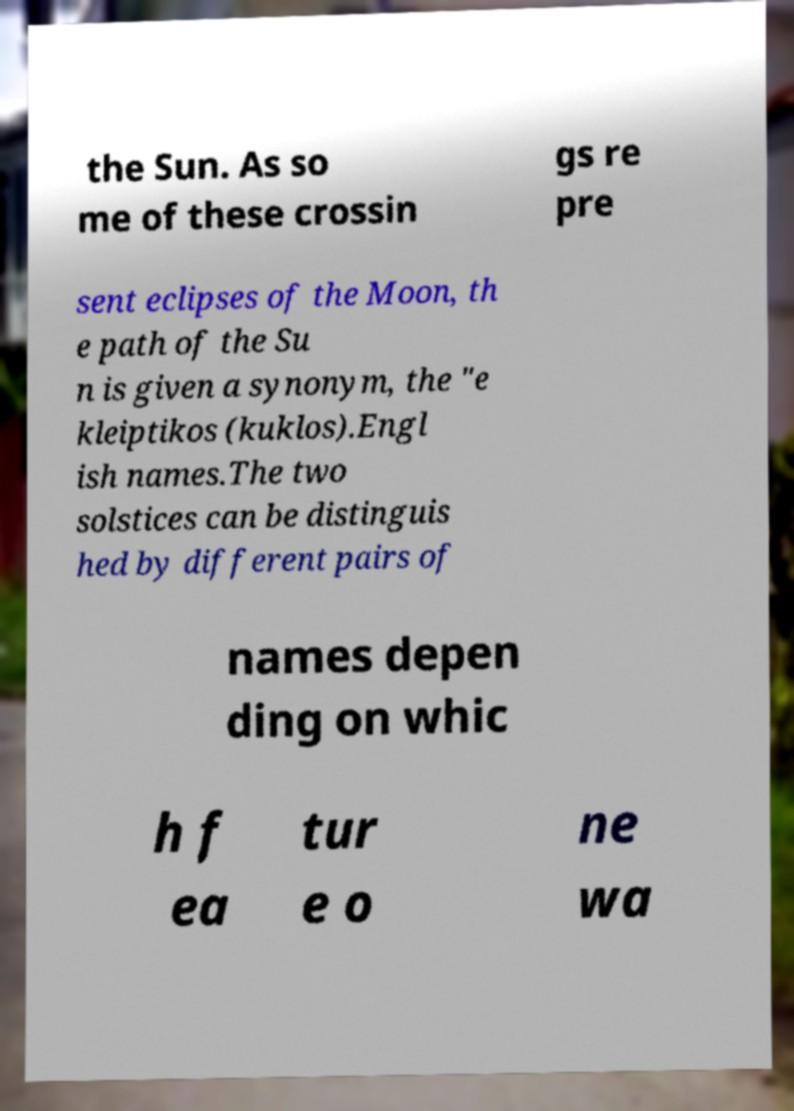What messages or text are displayed in this image? I need them in a readable, typed format. the Sun. As so me of these crossin gs re pre sent eclipses of the Moon, th e path of the Su n is given a synonym, the "e kleiptikos (kuklos).Engl ish names.The two solstices can be distinguis hed by different pairs of names depen ding on whic h f ea tur e o ne wa 